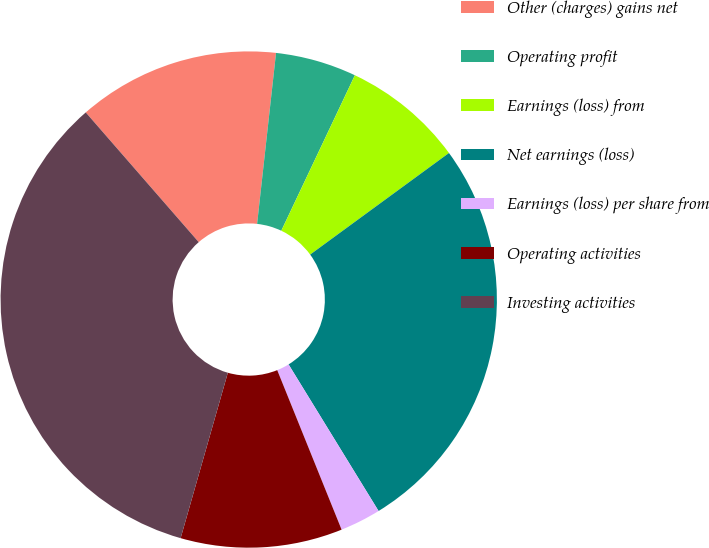<chart> <loc_0><loc_0><loc_500><loc_500><pie_chart><fcel>Other (charges) gains net<fcel>Operating profit<fcel>Earnings (loss) from<fcel>Net earnings (loss)<fcel>Earnings (loss) per share from<fcel>Operating activities<fcel>Investing activities<nl><fcel>13.16%<fcel>5.28%<fcel>7.91%<fcel>26.29%<fcel>2.66%<fcel>10.53%<fcel>34.17%<nl></chart> 